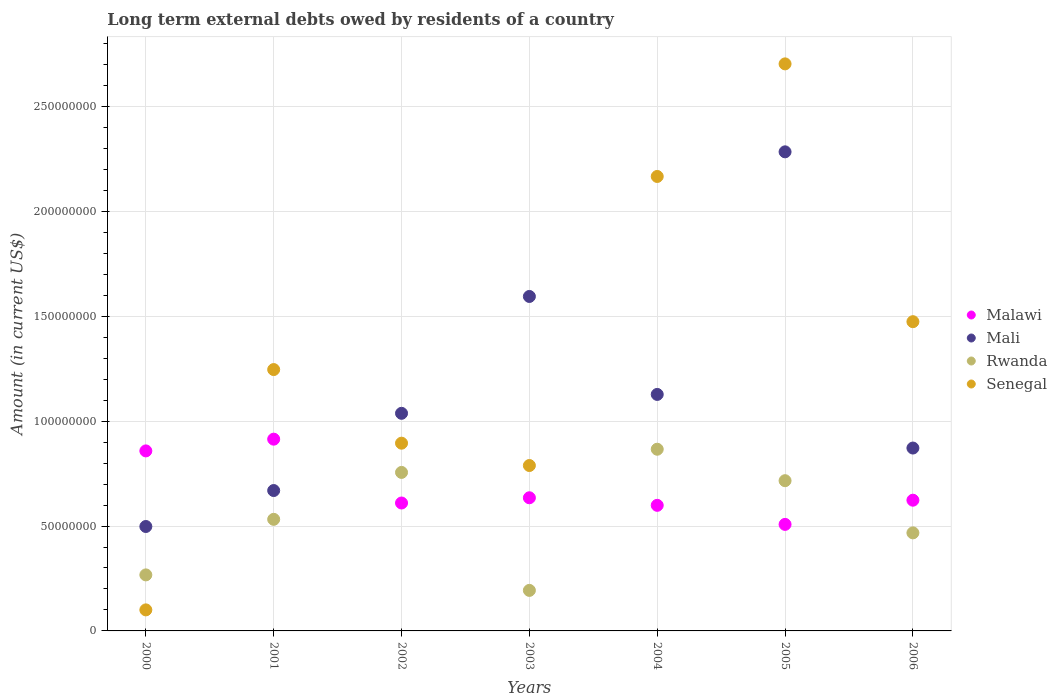How many different coloured dotlines are there?
Provide a short and direct response. 4. Is the number of dotlines equal to the number of legend labels?
Your answer should be very brief. Yes. What is the amount of long-term external debts owed by residents in Senegal in 2004?
Offer a very short reply. 2.17e+08. Across all years, what is the maximum amount of long-term external debts owed by residents in Malawi?
Offer a terse response. 9.14e+07. Across all years, what is the minimum amount of long-term external debts owed by residents in Rwanda?
Your response must be concise. 1.93e+07. In which year was the amount of long-term external debts owed by residents in Malawi maximum?
Offer a very short reply. 2001. In which year was the amount of long-term external debts owed by residents in Senegal minimum?
Offer a terse response. 2000. What is the total amount of long-term external debts owed by residents in Senegal in the graph?
Your response must be concise. 9.37e+08. What is the difference between the amount of long-term external debts owed by residents in Senegal in 2000 and that in 2004?
Provide a short and direct response. -2.07e+08. What is the difference between the amount of long-term external debts owed by residents in Rwanda in 2003 and the amount of long-term external debts owed by residents in Senegal in 2005?
Make the answer very short. -2.51e+08. What is the average amount of long-term external debts owed by residents in Senegal per year?
Your answer should be compact. 1.34e+08. In the year 2001, what is the difference between the amount of long-term external debts owed by residents in Mali and amount of long-term external debts owed by residents in Rwanda?
Ensure brevity in your answer.  1.37e+07. In how many years, is the amount of long-term external debts owed by residents in Senegal greater than 260000000 US$?
Provide a short and direct response. 1. What is the ratio of the amount of long-term external debts owed by residents in Senegal in 2000 to that in 2002?
Offer a very short reply. 0.11. Is the amount of long-term external debts owed by residents in Mali in 2000 less than that in 2001?
Offer a very short reply. Yes. Is the difference between the amount of long-term external debts owed by residents in Mali in 2002 and 2003 greater than the difference between the amount of long-term external debts owed by residents in Rwanda in 2002 and 2003?
Provide a short and direct response. No. What is the difference between the highest and the second highest amount of long-term external debts owed by residents in Senegal?
Your answer should be compact. 5.37e+07. What is the difference between the highest and the lowest amount of long-term external debts owed by residents in Senegal?
Provide a succinct answer. 2.60e+08. Is it the case that in every year, the sum of the amount of long-term external debts owed by residents in Senegal and amount of long-term external debts owed by residents in Mali  is greater than the sum of amount of long-term external debts owed by residents in Rwanda and amount of long-term external debts owed by residents in Malawi?
Make the answer very short. No. Is it the case that in every year, the sum of the amount of long-term external debts owed by residents in Malawi and amount of long-term external debts owed by residents in Mali  is greater than the amount of long-term external debts owed by residents in Rwanda?
Ensure brevity in your answer.  Yes. Does the amount of long-term external debts owed by residents in Malawi monotonically increase over the years?
Make the answer very short. No. Is the amount of long-term external debts owed by residents in Senegal strictly greater than the amount of long-term external debts owed by residents in Mali over the years?
Offer a very short reply. No. How many dotlines are there?
Provide a succinct answer. 4. How many years are there in the graph?
Your answer should be compact. 7. What is the difference between two consecutive major ticks on the Y-axis?
Give a very brief answer. 5.00e+07. Does the graph contain any zero values?
Your response must be concise. No. Where does the legend appear in the graph?
Provide a short and direct response. Center right. How many legend labels are there?
Give a very brief answer. 4. How are the legend labels stacked?
Provide a short and direct response. Vertical. What is the title of the graph?
Make the answer very short. Long term external debts owed by residents of a country. Does "Oman" appear as one of the legend labels in the graph?
Offer a very short reply. No. What is the label or title of the Y-axis?
Make the answer very short. Amount (in current US$). What is the Amount (in current US$) in Malawi in 2000?
Offer a very short reply. 8.58e+07. What is the Amount (in current US$) in Mali in 2000?
Your answer should be very brief. 4.98e+07. What is the Amount (in current US$) in Rwanda in 2000?
Offer a terse response. 2.67e+07. What is the Amount (in current US$) in Senegal in 2000?
Ensure brevity in your answer.  1.00e+07. What is the Amount (in current US$) in Malawi in 2001?
Provide a succinct answer. 9.14e+07. What is the Amount (in current US$) of Mali in 2001?
Give a very brief answer. 6.69e+07. What is the Amount (in current US$) in Rwanda in 2001?
Offer a very short reply. 5.32e+07. What is the Amount (in current US$) of Senegal in 2001?
Keep it short and to the point. 1.25e+08. What is the Amount (in current US$) in Malawi in 2002?
Give a very brief answer. 6.10e+07. What is the Amount (in current US$) of Mali in 2002?
Ensure brevity in your answer.  1.04e+08. What is the Amount (in current US$) of Rwanda in 2002?
Your answer should be compact. 7.56e+07. What is the Amount (in current US$) of Senegal in 2002?
Offer a terse response. 8.95e+07. What is the Amount (in current US$) in Malawi in 2003?
Your answer should be compact. 6.35e+07. What is the Amount (in current US$) of Mali in 2003?
Your answer should be compact. 1.59e+08. What is the Amount (in current US$) in Rwanda in 2003?
Ensure brevity in your answer.  1.93e+07. What is the Amount (in current US$) in Senegal in 2003?
Ensure brevity in your answer.  7.88e+07. What is the Amount (in current US$) of Malawi in 2004?
Provide a succinct answer. 5.99e+07. What is the Amount (in current US$) of Mali in 2004?
Your answer should be very brief. 1.13e+08. What is the Amount (in current US$) of Rwanda in 2004?
Your answer should be very brief. 8.66e+07. What is the Amount (in current US$) of Senegal in 2004?
Provide a succinct answer. 2.17e+08. What is the Amount (in current US$) in Malawi in 2005?
Your answer should be compact. 5.08e+07. What is the Amount (in current US$) in Mali in 2005?
Your answer should be very brief. 2.28e+08. What is the Amount (in current US$) of Rwanda in 2005?
Offer a terse response. 7.16e+07. What is the Amount (in current US$) in Senegal in 2005?
Keep it short and to the point. 2.70e+08. What is the Amount (in current US$) of Malawi in 2006?
Offer a very short reply. 6.23e+07. What is the Amount (in current US$) of Mali in 2006?
Your answer should be very brief. 8.72e+07. What is the Amount (in current US$) in Rwanda in 2006?
Your answer should be compact. 4.67e+07. What is the Amount (in current US$) in Senegal in 2006?
Make the answer very short. 1.47e+08. Across all years, what is the maximum Amount (in current US$) of Malawi?
Provide a short and direct response. 9.14e+07. Across all years, what is the maximum Amount (in current US$) of Mali?
Your answer should be very brief. 2.28e+08. Across all years, what is the maximum Amount (in current US$) in Rwanda?
Keep it short and to the point. 8.66e+07. Across all years, what is the maximum Amount (in current US$) of Senegal?
Give a very brief answer. 2.70e+08. Across all years, what is the minimum Amount (in current US$) in Malawi?
Make the answer very short. 5.08e+07. Across all years, what is the minimum Amount (in current US$) in Mali?
Give a very brief answer. 4.98e+07. Across all years, what is the minimum Amount (in current US$) of Rwanda?
Give a very brief answer. 1.93e+07. Across all years, what is the minimum Amount (in current US$) of Senegal?
Your response must be concise. 1.00e+07. What is the total Amount (in current US$) in Malawi in the graph?
Give a very brief answer. 4.75e+08. What is the total Amount (in current US$) of Mali in the graph?
Your response must be concise. 8.08e+08. What is the total Amount (in current US$) in Rwanda in the graph?
Provide a succinct answer. 3.80e+08. What is the total Amount (in current US$) in Senegal in the graph?
Ensure brevity in your answer.  9.37e+08. What is the difference between the Amount (in current US$) of Malawi in 2000 and that in 2001?
Offer a terse response. -5.60e+06. What is the difference between the Amount (in current US$) of Mali in 2000 and that in 2001?
Give a very brief answer. -1.71e+07. What is the difference between the Amount (in current US$) of Rwanda in 2000 and that in 2001?
Provide a short and direct response. -2.65e+07. What is the difference between the Amount (in current US$) of Senegal in 2000 and that in 2001?
Your response must be concise. -1.15e+08. What is the difference between the Amount (in current US$) of Malawi in 2000 and that in 2002?
Offer a terse response. 2.48e+07. What is the difference between the Amount (in current US$) of Mali in 2000 and that in 2002?
Provide a succinct answer. -5.40e+07. What is the difference between the Amount (in current US$) in Rwanda in 2000 and that in 2002?
Provide a succinct answer. -4.89e+07. What is the difference between the Amount (in current US$) in Senegal in 2000 and that in 2002?
Provide a succinct answer. -7.95e+07. What is the difference between the Amount (in current US$) in Malawi in 2000 and that in 2003?
Provide a short and direct response. 2.23e+07. What is the difference between the Amount (in current US$) of Mali in 2000 and that in 2003?
Provide a short and direct response. -1.10e+08. What is the difference between the Amount (in current US$) in Rwanda in 2000 and that in 2003?
Your response must be concise. 7.39e+06. What is the difference between the Amount (in current US$) of Senegal in 2000 and that in 2003?
Ensure brevity in your answer.  -6.88e+07. What is the difference between the Amount (in current US$) in Malawi in 2000 and that in 2004?
Make the answer very short. 2.59e+07. What is the difference between the Amount (in current US$) of Mali in 2000 and that in 2004?
Your response must be concise. -6.30e+07. What is the difference between the Amount (in current US$) of Rwanda in 2000 and that in 2004?
Give a very brief answer. -5.99e+07. What is the difference between the Amount (in current US$) of Senegal in 2000 and that in 2004?
Your answer should be very brief. -2.07e+08. What is the difference between the Amount (in current US$) of Malawi in 2000 and that in 2005?
Provide a succinct answer. 3.50e+07. What is the difference between the Amount (in current US$) of Mali in 2000 and that in 2005?
Provide a short and direct response. -1.79e+08. What is the difference between the Amount (in current US$) of Rwanda in 2000 and that in 2005?
Your answer should be very brief. -4.49e+07. What is the difference between the Amount (in current US$) of Senegal in 2000 and that in 2005?
Provide a succinct answer. -2.60e+08. What is the difference between the Amount (in current US$) in Malawi in 2000 and that in 2006?
Provide a succinct answer. 2.35e+07. What is the difference between the Amount (in current US$) in Mali in 2000 and that in 2006?
Your answer should be compact. -3.74e+07. What is the difference between the Amount (in current US$) of Rwanda in 2000 and that in 2006?
Your answer should be compact. -2.00e+07. What is the difference between the Amount (in current US$) in Senegal in 2000 and that in 2006?
Give a very brief answer. -1.37e+08. What is the difference between the Amount (in current US$) of Malawi in 2001 and that in 2002?
Your answer should be very brief. 3.04e+07. What is the difference between the Amount (in current US$) in Mali in 2001 and that in 2002?
Ensure brevity in your answer.  -3.68e+07. What is the difference between the Amount (in current US$) in Rwanda in 2001 and that in 2002?
Make the answer very short. -2.24e+07. What is the difference between the Amount (in current US$) of Senegal in 2001 and that in 2002?
Your answer should be compact. 3.51e+07. What is the difference between the Amount (in current US$) of Malawi in 2001 and that in 2003?
Keep it short and to the point. 2.79e+07. What is the difference between the Amount (in current US$) of Mali in 2001 and that in 2003?
Provide a short and direct response. -9.25e+07. What is the difference between the Amount (in current US$) in Rwanda in 2001 and that in 2003?
Your answer should be very brief. 3.39e+07. What is the difference between the Amount (in current US$) of Senegal in 2001 and that in 2003?
Your response must be concise. 4.57e+07. What is the difference between the Amount (in current US$) of Malawi in 2001 and that in 2004?
Provide a succinct answer. 3.15e+07. What is the difference between the Amount (in current US$) of Mali in 2001 and that in 2004?
Offer a very short reply. -4.58e+07. What is the difference between the Amount (in current US$) of Rwanda in 2001 and that in 2004?
Keep it short and to the point. -3.34e+07. What is the difference between the Amount (in current US$) of Senegal in 2001 and that in 2004?
Offer a terse response. -9.21e+07. What is the difference between the Amount (in current US$) of Malawi in 2001 and that in 2005?
Your response must be concise. 4.06e+07. What is the difference between the Amount (in current US$) of Mali in 2001 and that in 2005?
Provide a short and direct response. -1.61e+08. What is the difference between the Amount (in current US$) of Rwanda in 2001 and that in 2005?
Your answer should be compact. -1.84e+07. What is the difference between the Amount (in current US$) of Senegal in 2001 and that in 2005?
Offer a terse response. -1.46e+08. What is the difference between the Amount (in current US$) of Malawi in 2001 and that in 2006?
Your answer should be very brief. 2.91e+07. What is the difference between the Amount (in current US$) of Mali in 2001 and that in 2006?
Your response must be concise. -2.03e+07. What is the difference between the Amount (in current US$) in Rwanda in 2001 and that in 2006?
Your response must be concise. 6.45e+06. What is the difference between the Amount (in current US$) in Senegal in 2001 and that in 2006?
Offer a very short reply. -2.28e+07. What is the difference between the Amount (in current US$) in Malawi in 2002 and that in 2003?
Your response must be concise. -2.49e+06. What is the difference between the Amount (in current US$) of Mali in 2002 and that in 2003?
Make the answer very short. -5.57e+07. What is the difference between the Amount (in current US$) of Rwanda in 2002 and that in 2003?
Offer a very short reply. 5.62e+07. What is the difference between the Amount (in current US$) of Senegal in 2002 and that in 2003?
Provide a short and direct response. 1.07e+07. What is the difference between the Amount (in current US$) of Malawi in 2002 and that in 2004?
Offer a terse response. 1.11e+06. What is the difference between the Amount (in current US$) in Mali in 2002 and that in 2004?
Make the answer very short. -9.00e+06. What is the difference between the Amount (in current US$) in Rwanda in 2002 and that in 2004?
Your answer should be very brief. -1.11e+07. What is the difference between the Amount (in current US$) of Senegal in 2002 and that in 2004?
Ensure brevity in your answer.  -1.27e+08. What is the difference between the Amount (in current US$) of Malawi in 2002 and that in 2005?
Provide a short and direct response. 1.02e+07. What is the difference between the Amount (in current US$) of Mali in 2002 and that in 2005?
Provide a succinct answer. -1.25e+08. What is the difference between the Amount (in current US$) of Rwanda in 2002 and that in 2005?
Provide a succinct answer. 3.94e+06. What is the difference between the Amount (in current US$) in Senegal in 2002 and that in 2005?
Your answer should be compact. -1.81e+08. What is the difference between the Amount (in current US$) of Malawi in 2002 and that in 2006?
Ensure brevity in your answer.  -1.34e+06. What is the difference between the Amount (in current US$) of Mali in 2002 and that in 2006?
Your answer should be very brief. 1.66e+07. What is the difference between the Amount (in current US$) of Rwanda in 2002 and that in 2006?
Your response must be concise. 2.88e+07. What is the difference between the Amount (in current US$) of Senegal in 2002 and that in 2006?
Offer a very short reply. -5.79e+07. What is the difference between the Amount (in current US$) in Malawi in 2003 and that in 2004?
Offer a very short reply. 3.60e+06. What is the difference between the Amount (in current US$) in Mali in 2003 and that in 2004?
Provide a succinct answer. 4.67e+07. What is the difference between the Amount (in current US$) of Rwanda in 2003 and that in 2004?
Your response must be concise. -6.73e+07. What is the difference between the Amount (in current US$) in Senegal in 2003 and that in 2004?
Your answer should be compact. -1.38e+08. What is the difference between the Amount (in current US$) of Malawi in 2003 and that in 2005?
Offer a very short reply. 1.27e+07. What is the difference between the Amount (in current US$) in Mali in 2003 and that in 2005?
Provide a short and direct response. -6.89e+07. What is the difference between the Amount (in current US$) in Rwanda in 2003 and that in 2005?
Give a very brief answer. -5.23e+07. What is the difference between the Amount (in current US$) in Senegal in 2003 and that in 2005?
Provide a succinct answer. -1.91e+08. What is the difference between the Amount (in current US$) in Malawi in 2003 and that in 2006?
Provide a succinct answer. 1.15e+06. What is the difference between the Amount (in current US$) of Mali in 2003 and that in 2006?
Offer a very short reply. 7.23e+07. What is the difference between the Amount (in current US$) of Rwanda in 2003 and that in 2006?
Your answer should be very brief. -2.74e+07. What is the difference between the Amount (in current US$) of Senegal in 2003 and that in 2006?
Keep it short and to the point. -6.86e+07. What is the difference between the Amount (in current US$) in Malawi in 2004 and that in 2005?
Offer a terse response. 9.09e+06. What is the difference between the Amount (in current US$) in Mali in 2004 and that in 2005?
Provide a short and direct response. -1.16e+08. What is the difference between the Amount (in current US$) in Rwanda in 2004 and that in 2005?
Provide a succinct answer. 1.50e+07. What is the difference between the Amount (in current US$) in Senegal in 2004 and that in 2005?
Make the answer very short. -5.37e+07. What is the difference between the Amount (in current US$) in Malawi in 2004 and that in 2006?
Give a very brief answer. -2.45e+06. What is the difference between the Amount (in current US$) in Mali in 2004 and that in 2006?
Provide a succinct answer. 2.56e+07. What is the difference between the Amount (in current US$) in Rwanda in 2004 and that in 2006?
Ensure brevity in your answer.  3.99e+07. What is the difference between the Amount (in current US$) of Senegal in 2004 and that in 2006?
Give a very brief answer. 6.92e+07. What is the difference between the Amount (in current US$) of Malawi in 2005 and that in 2006?
Offer a very short reply. -1.15e+07. What is the difference between the Amount (in current US$) in Mali in 2005 and that in 2006?
Your response must be concise. 1.41e+08. What is the difference between the Amount (in current US$) in Rwanda in 2005 and that in 2006?
Make the answer very short. 2.49e+07. What is the difference between the Amount (in current US$) in Senegal in 2005 and that in 2006?
Offer a terse response. 1.23e+08. What is the difference between the Amount (in current US$) in Malawi in 2000 and the Amount (in current US$) in Mali in 2001?
Give a very brief answer. 1.89e+07. What is the difference between the Amount (in current US$) in Malawi in 2000 and the Amount (in current US$) in Rwanda in 2001?
Your answer should be compact. 3.26e+07. What is the difference between the Amount (in current US$) of Malawi in 2000 and the Amount (in current US$) of Senegal in 2001?
Make the answer very short. -3.88e+07. What is the difference between the Amount (in current US$) in Mali in 2000 and the Amount (in current US$) in Rwanda in 2001?
Keep it short and to the point. -3.42e+06. What is the difference between the Amount (in current US$) in Mali in 2000 and the Amount (in current US$) in Senegal in 2001?
Provide a succinct answer. -7.48e+07. What is the difference between the Amount (in current US$) in Rwanda in 2000 and the Amount (in current US$) in Senegal in 2001?
Your response must be concise. -9.79e+07. What is the difference between the Amount (in current US$) of Malawi in 2000 and the Amount (in current US$) of Mali in 2002?
Offer a terse response. -1.79e+07. What is the difference between the Amount (in current US$) in Malawi in 2000 and the Amount (in current US$) in Rwanda in 2002?
Your answer should be compact. 1.03e+07. What is the difference between the Amount (in current US$) of Malawi in 2000 and the Amount (in current US$) of Senegal in 2002?
Make the answer very short. -3.68e+06. What is the difference between the Amount (in current US$) in Mali in 2000 and the Amount (in current US$) in Rwanda in 2002?
Give a very brief answer. -2.58e+07. What is the difference between the Amount (in current US$) in Mali in 2000 and the Amount (in current US$) in Senegal in 2002?
Offer a very short reply. -3.97e+07. What is the difference between the Amount (in current US$) in Rwanda in 2000 and the Amount (in current US$) in Senegal in 2002?
Provide a short and direct response. -6.28e+07. What is the difference between the Amount (in current US$) in Malawi in 2000 and the Amount (in current US$) in Mali in 2003?
Your response must be concise. -7.36e+07. What is the difference between the Amount (in current US$) in Malawi in 2000 and the Amount (in current US$) in Rwanda in 2003?
Your answer should be very brief. 6.65e+07. What is the difference between the Amount (in current US$) in Malawi in 2000 and the Amount (in current US$) in Senegal in 2003?
Keep it short and to the point. 6.97e+06. What is the difference between the Amount (in current US$) in Mali in 2000 and the Amount (in current US$) in Rwanda in 2003?
Offer a terse response. 3.05e+07. What is the difference between the Amount (in current US$) in Mali in 2000 and the Amount (in current US$) in Senegal in 2003?
Give a very brief answer. -2.91e+07. What is the difference between the Amount (in current US$) of Rwanda in 2000 and the Amount (in current US$) of Senegal in 2003?
Your answer should be compact. -5.21e+07. What is the difference between the Amount (in current US$) of Malawi in 2000 and the Amount (in current US$) of Mali in 2004?
Give a very brief answer. -2.69e+07. What is the difference between the Amount (in current US$) in Malawi in 2000 and the Amount (in current US$) in Rwanda in 2004?
Give a very brief answer. -7.97e+05. What is the difference between the Amount (in current US$) of Malawi in 2000 and the Amount (in current US$) of Senegal in 2004?
Give a very brief answer. -1.31e+08. What is the difference between the Amount (in current US$) of Mali in 2000 and the Amount (in current US$) of Rwanda in 2004?
Offer a terse response. -3.68e+07. What is the difference between the Amount (in current US$) in Mali in 2000 and the Amount (in current US$) in Senegal in 2004?
Provide a succinct answer. -1.67e+08. What is the difference between the Amount (in current US$) of Rwanda in 2000 and the Amount (in current US$) of Senegal in 2004?
Your answer should be very brief. -1.90e+08. What is the difference between the Amount (in current US$) of Malawi in 2000 and the Amount (in current US$) of Mali in 2005?
Offer a very short reply. -1.43e+08. What is the difference between the Amount (in current US$) of Malawi in 2000 and the Amount (in current US$) of Rwanda in 2005?
Provide a short and direct response. 1.42e+07. What is the difference between the Amount (in current US$) in Malawi in 2000 and the Amount (in current US$) in Senegal in 2005?
Your answer should be very brief. -1.84e+08. What is the difference between the Amount (in current US$) of Mali in 2000 and the Amount (in current US$) of Rwanda in 2005?
Your answer should be compact. -2.18e+07. What is the difference between the Amount (in current US$) in Mali in 2000 and the Amount (in current US$) in Senegal in 2005?
Your response must be concise. -2.21e+08. What is the difference between the Amount (in current US$) in Rwanda in 2000 and the Amount (in current US$) in Senegal in 2005?
Ensure brevity in your answer.  -2.44e+08. What is the difference between the Amount (in current US$) of Malawi in 2000 and the Amount (in current US$) of Mali in 2006?
Your response must be concise. -1.36e+06. What is the difference between the Amount (in current US$) of Malawi in 2000 and the Amount (in current US$) of Rwanda in 2006?
Ensure brevity in your answer.  3.91e+07. What is the difference between the Amount (in current US$) of Malawi in 2000 and the Amount (in current US$) of Senegal in 2006?
Offer a terse response. -6.16e+07. What is the difference between the Amount (in current US$) of Mali in 2000 and the Amount (in current US$) of Rwanda in 2006?
Ensure brevity in your answer.  3.04e+06. What is the difference between the Amount (in current US$) in Mali in 2000 and the Amount (in current US$) in Senegal in 2006?
Keep it short and to the point. -9.76e+07. What is the difference between the Amount (in current US$) of Rwanda in 2000 and the Amount (in current US$) of Senegal in 2006?
Your response must be concise. -1.21e+08. What is the difference between the Amount (in current US$) of Malawi in 2001 and the Amount (in current US$) of Mali in 2002?
Your answer should be compact. -1.23e+07. What is the difference between the Amount (in current US$) of Malawi in 2001 and the Amount (in current US$) of Rwanda in 2002?
Ensure brevity in your answer.  1.59e+07. What is the difference between the Amount (in current US$) of Malawi in 2001 and the Amount (in current US$) of Senegal in 2002?
Your answer should be compact. 1.91e+06. What is the difference between the Amount (in current US$) of Mali in 2001 and the Amount (in current US$) of Rwanda in 2002?
Your answer should be compact. -8.64e+06. What is the difference between the Amount (in current US$) in Mali in 2001 and the Amount (in current US$) in Senegal in 2002?
Provide a succinct answer. -2.26e+07. What is the difference between the Amount (in current US$) in Rwanda in 2001 and the Amount (in current US$) in Senegal in 2002?
Your answer should be compact. -3.63e+07. What is the difference between the Amount (in current US$) of Malawi in 2001 and the Amount (in current US$) of Mali in 2003?
Offer a terse response. -6.80e+07. What is the difference between the Amount (in current US$) in Malawi in 2001 and the Amount (in current US$) in Rwanda in 2003?
Keep it short and to the point. 7.21e+07. What is the difference between the Amount (in current US$) in Malawi in 2001 and the Amount (in current US$) in Senegal in 2003?
Ensure brevity in your answer.  1.26e+07. What is the difference between the Amount (in current US$) of Mali in 2001 and the Amount (in current US$) of Rwanda in 2003?
Keep it short and to the point. 4.76e+07. What is the difference between the Amount (in current US$) of Mali in 2001 and the Amount (in current US$) of Senegal in 2003?
Your answer should be compact. -1.19e+07. What is the difference between the Amount (in current US$) in Rwanda in 2001 and the Amount (in current US$) in Senegal in 2003?
Your answer should be very brief. -2.57e+07. What is the difference between the Amount (in current US$) of Malawi in 2001 and the Amount (in current US$) of Mali in 2004?
Offer a very short reply. -2.13e+07. What is the difference between the Amount (in current US$) of Malawi in 2001 and the Amount (in current US$) of Rwanda in 2004?
Offer a very short reply. 4.80e+06. What is the difference between the Amount (in current US$) of Malawi in 2001 and the Amount (in current US$) of Senegal in 2004?
Offer a very short reply. -1.25e+08. What is the difference between the Amount (in current US$) in Mali in 2001 and the Amount (in current US$) in Rwanda in 2004?
Make the answer very short. -1.97e+07. What is the difference between the Amount (in current US$) in Mali in 2001 and the Amount (in current US$) in Senegal in 2004?
Offer a very short reply. -1.50e+08. What is the difference between the Amount (in current US$) of Rwanda in 2001 and the Amount (in current US$) of Senegal in 2004?
Offer a terse response. -1.63e+08. What is the difference between the Amount (in current US$) of Malawi in 2001 and the Amount (in current US$) of Mali in 2005?
Your response must be concise. -1.37e+08. What is the difference between the Amount (in current US$) of Malawi in 2001 and the Amount (in current US$) of Rwanda in 2005?
Give a very brief answer. 1.98e+07. What is the difference between the Amount (in current US$) in Malawi in 2001 and the Amount (in current US$) in Senegal in 2005?
Offer a terse response. -1.79e+08. What is the difference between the Amount (in current US$) in Mali in 2001 and the Amount (in current US$) in Rwanda in 2005?
Provide a short and direct response. -4.70e+06. What is the difference between the Amount (in current US$) of Mali in 2001 and the Amount (in current US$) of Senegal in 2005?
Keep it short and to the point. -2.03e+08. What is the difference between the Amount (in current US$) in Rwanda in 2001 and the Amount (in current US$) in Senegal in 2005?
Offer a very short reply. -2.17e+08. What is the difference between the Amount (in current US$) in Malawi in 2001 and the Amount (in current US$) in Mali in 2006?
Your answer should be compact. 4.23e+06. What is the difference between the Amount (in current US$) in Malawi in 2001 and the Amount (in current US$) in Rwanda in 2006?
Your answer should be compact. 4.47e+07. What is the difference between the Amount (in current US$) in Malawi in 2001 and the Amount (in current US$) in Senegal in 2006?
Provide a short and direct response. -5.60e+07. What is the difference between the Amount (in current US$) of Mali in 2001 and the Amount (in current US$) of Rwanda in 2006?
Make the answer very short. 2.02e+07. What is the difference between the Amount (in current US$) in Mali in 2001 and the Amount (in current US$) in Senegal in 2006?
Provide a short and direct response. -8.05e+07. What is the difference between the Amount (in current US$) of Rwanda in 2001 and the Amount (in current US$) of Senegal in 2006?
Give a very brief answer. -9.42e+07. What is the difference between the Amount (in current US$) in Malawi in 2002 and the Amount (in current US$) in Mali in 2003?
Your answer should be very brief. -9.85e+07. What is the difference between the Amount (in current US$) of Malawi in 2002 and the Amount (in current US$) of Rwanda in 2003?
Your answer should be very brief. 4.17e+07. What is the difference between the Amount (in current US$) of Malawi in 2002 and the Amount (in current US$) of Senegal in 2003?
Your answer should be very brief. -1.79e+07. What is the difference between the Amount (in current US$) in Mali in 2002 and the Amount (in current US$) in Rwanda in 2003?
Provide a succinct answer. 8.44e+07. What is the difference between the Amount (in current US$) in Mali in 2002 and the Amount (in current US$) in Senegal in 2003?
Keep it short and to the point. 2.49e+07. What is the difference between the Amount (in current US$) in Rwanda in 2002 and the Amount (in current US$) in Senegal in 2003?
Offer a terse response. -3.28e+06. What is the difference between the Amount (in current US$) of Malawi in 2002 and the Amount (in current US$) of Mali in 2004?
Give a very brief answer. -5.18e+07. What is the difference between the Amount (in current US$) in Malawi in 2002 and the Amount (in current US$) in Rwanda in 2004?
Provide a short and direct response. -2.56e+07. What is the difference between the Amount (in current US$) in Malawi in 2002 and the Amount (in current US$) in Senegal in 2004?
Ensure brevity in your answer.  -1.56e+08. What is the difference between the Amount (in current US$) of Mali in 2002 and the Amount (in current US$) of Rwanda in 2004?
Your answer should be very brief. 1.71e+07. What is the difference between the Amount (in current US$) of Mali in 2002 and the Amount (in current US$) of Senegal in 2004?
Your response must be concise. -1.13e+08. What is the difference between the Amount (in current US$) of Rwanda in 2002 and the Amount (in current US$) of Senegal in 2004?
Give a very brief answer. -1.41e+08. What is the difference between the Amount (in current US$) of Malawi in 2002 and the Amount (in current US$) of Mali in 2005?
Offer a terse response. -1.67e+08. What is the difference between the Amount (in current US$) of Malawi in 2002 and the Amount (in current US$) of Rwanda in 2005?
Offer a terse response. -1.06e+07. What is the difference between the Amount (in current US$) of Malawi in 2002 and the Amount (in current US$) of Senegal in 2005?
Give a very brief answer. -2.09e+08. What is the difference between the Amount (in current US$) in Mali in 2002 and the Amount (in current US$) in Rwanda in 2005?
Provide a short and direct response. 3.21e+07. What is the difference between the Amount (in current US$) in Mali in 2002 and the Amount (in current US$) in Senegal in 2005?
Give a very brief answer. -1.67e+08. What is the difference between the Amount (in current US$) in Rwanda in 2002 and the Amount (in current US$) in Senegal in 2005?
Offer a very short reply. -1.95e+08. What is the difference between the Amount (in current US$) of Malawi in 2002 and the Amount (in current US$) of Mali in 2006?
Provide a succinct answer. -2.62e+07. What is the difference between the Amount (in current US$) in Malawi in 2002 and the Amount (in current US$) in Rwanda in 2006?
Offer a very short reply. 1.42e+07. What is the difference between the Amount (in current US$) of Malawi in 2002 and the Amount (in current US$) of Senegal in 2006?
Offer a terse response. -8.64e+07. What is the difference between the Amount (in current US$) of Mali in 2002 and the Amount (in current US$) of Rwanda in 2006?
Offer a terse response. 5.70e+07. What is the difference between the Amount (in current US$) in Mali in 2002 and the Amount (in current US$) in Senegal in 2006?
Your answer should be compact. -4.37e+07. What is the difference between the Amount (in current US$) in Rwanda in 2002 and the Amount (in current US$) in Senegal in 2006?
Your answer should be compact. -7.19e+07. What is the difference between the Amount (in current US$) in Malawi in 2003 and the Amount (in current US$) in Mali in 2004?
Keep it short and to the point. -4.93e+07. What is the difference between the Amount (in current US$) of Malawi in 2003 and the Amount (in current US$) of Rwanda in 2004?
Ensure brevity in your answer.  -2.31e+07. What is the difference between the Amount (in current US$) in Malawi in 2003 and the Amount (in current US$) in Senegal in 2004?
Provide a short and direct response. -1.53e+08. What is the difference between the Amount (in current US$) of Mali in 2003 and the Amount (in current US$) of Rwanda in 2004?
Your response must be concise. 7.28e+07. What is the difference between the Amount (in current US$) in Mali in 2003 and the Amount (in current US$) in Senegal in 2004?
Your answer should be very brief. -5.72e+07. What is the difference between the Amount (in current US$) in Rwanda in 2003 and the Amount (in current US$) in Senegal in 2004?
Give a very brief answer. -1.97e+08. What is the difference between the Amount (in current US$) in Malawi in 2003 and the Amount (in current US$) in Mali in 2005?
Your answer should be compact. -1.65e+08. What is the difference between the Amount (in current US$) in Malawi in 2003 and the Amount (in current US$) in Rwanda in 2005?
Keep it short and to the point. -8.14e+06. What is the difference between the Amount (in current US$) in Malawi in 2003 and the Amount (in current US$) in Senegal in 2005?
Offer a very short reply. -2.07e+08. What is the difference between the Amount (in current US$) in Mali in 2003 and the Amount (in current US$) in Rwanda in 2005?
Offer a terse response. 8.78e+07. What is the difference between the Amount (in current US$) of Mali in 2003 and the Amount (in current US$) of Senegal in 2005?
Offer a terse response. -1.11e+08. What is the difference between the Amount (in current US$) of Rwanda in 2003 and the Amount (in current US$) of Senegal in 2005?
Keep it short and to the point. -2.51e+08. What is the difference between the Amount (in current US$) of Malawi in 2003 and the Amount (in current US$) of Mali in 2006?
Give a very brief answer. -2.37e+07. What is the difference between the Amount (in current US$) in Malawi in 2003 and the Amount (in current US$) in Rwanda in 2006?
Give a very brief answer. 1.67e+07. What is the difference between the Amount (in current US$) in Malawi in 2003 and the Amount (in current US$) in Senegal in 2006?
Provide a short and direct response. -8.39e+07. What is the difference between the Amount (in current US$) in Mali in 2003 and the Amount (in current US$) in Rwanda in 2006?
Make the answer very short. 1.13e+08. What is the difference between the Amount (in current US$) of Mali in 2003 and the Amount (in current US$) of Senegal in 2006?
Provide a succinct answer. 1.20e+07. What is the difference between the Amount (in current US$) in Rwanda in 2003 and the Amount (in current US$) in Senegal in 2006?
Ensure brevity in your answer.  -1.28e+08. What is the difference between the Amount (in current US$) in Malawi in 2004 and the Amount (in current US$) in Mali in 2005?
Ensure brevity in your answer.  -1.69e+08. What is the difference between the Amount (in current US$) in Malawi in 2004 and the Amount (in current US$) in Rwanda in 2005?
Offer a terse response. -1.17e+07. What is the difference between the Amount (in current US$) in Malawi in 2004 and the Amount (in current US$) in Senegal in 2005?
Your answer should be very brief. -2.10e+08. What is the difference between the Amount (in current US$) of Mali in 2004 and the Amount (in current US$) of Rwanda in 2005?
Your answer should be compact. 4.11e+07. What is the difference between the Amount (in current US$) in Mali in 2004 and the Amount (in current US$) in Senegal in 2005?
Provide a short and direct response. -1.58e+08. What is the difference between the Amount (in current US$) in Rwanda in 2004 and the Amount (in current US$) in Senegal in 2005?
Keep it short and to the point. -1.84e+08. What is the difference between the Amount (in current US$) in Malawi in 2004 and the Amount (in current US$) in Mali in 2006?
Your answer should be compact. -2.73e+07. What is the difference between the Amount (in current US$) of Malawi in 2004 and the Amount (in current US$) of Rwanda in 2006?
Give a very brief answer. 1.31e+07. What is the difference between the Amount (in current US$) in Malawi in 2004 and the Amount (in current US$) in Senegal in 2006?
Provide a succinct answer. -8.75e+07. What is the difference between the Amount (in current US$) of Mali in 2004 and the Amount (in current US$) of Rwanda in 2006?
Provide a short and direct response. 6.60e+07. What is the difference between the Amount (in current US$) of Mali in 2004 and the Amount (in current US$) of Senegal in 2006?
Ensure brevity in your answer.  -3.47e+07. What is the difference between the Amount (in current US$) of Rwanda in 2004 and the Amount (in current US$) of Senegal in 2006?
Ensure brevity in your answer.  -6.08e+07. What is the difference between the Amount (in current US$) in Malawi in 2005 and the Amount (in current US$) in Mali in 2006?
Provide a short and direct response. -3.64e+07. What is the difference between the Amount (in current US$) of Malawi in 2005 and the Amount (in current US$) of Rwanda in 2006?
Provide a succinct answer. 4.04e+06. What is the difference between the Amount (in current US$) of Malawi in 2005 and the Amount (in current US$) of Senegal in 2006?
Give a very brief answer. -9.66e+07. What is the difference between the Amount (in current US$) of Mali in 2005 and the Amount (in current US$) of Rwanda in 2006?
Your response must be concise. 1.82e+08. What is the difference between the Amount (in current US$) of Mali in 2005 and the Amount (in current US$) of Senegal in 2006?
Ensure brevity in your answer.  8.10e+07. What is the difference between the Amount (in current US$) in Rwanda in 2005 and the Amount (in current US$) in Senegal in 2006?
Make the answer very short. -7.58e+07. What is the average Amount (in current US$) of Malawi per year?
Keep it short and to the point. 6.78e+07. What is the average Amount (in current US$) of Mali per year?
Ensure brevity in your answer.  1.15e+08. What is the average Amount (in current US$) of Rwanda per year?
Ensure brevity in your answer.  5.43e+07. What is the average Amount (in current US$) in Senegal per year?
Give a very brief answer. 1.34e+08. In the year 2000, what is the difference between the Amount (in current US$) of Malawi and Amount (in current US$) of Mali?
Ensure brevity in your answer.  3.60e+07. In the year 2000, what is the difference between the Amount (in current US$) in Malawi and Amount (in current US$) in Rwanda?
Provide a short and direct response. 5.91e+07. In the year 2000, what is the difference between the Amount (in current US$) in Malawi and Amount (in current US$) in Senegal?
Make the answer very short. 7.58e+07. In the year 2000, what is the difference between the Amount (in current US$) in Mali and Amount (in current US$) in Rwanda?
Your response must be concise. 2.31e+07. In the year 2000, what is the difference between the Amount (in current US$) of Mali and Amount (in current US$) of Senegal?
Offer a very short reply. 3.97e+07. In the year 2000, what is the difference between the Amount (in current US$) of Rwanda and Amount (in current US$) of Senegal?
Your response must be concise. 1.67e+07. In the year 2001, what is the difference between the Amount (in current US$) in Malawi and Amount (in current US$) in Mali?
Provide a short and direct response. 2.45e+07. In the year 2001, what is the difference between the Amount (in current US$) of Malawi and Amount (in current US$) of Rwanda?
Provide a short and direct response. 3.82e+07. In the year 2001, what is the difference between the Amount (in current US$) of Malawi and Amount (in current US$) of Senegal?
Offer a very short reply. -3.32e+07. In the year 2001, what is the difference between the Amount (in current US$) in Mali and Amount (in current US$) in Rwanda?
Ensure brevity in your answer.  1.37e+07. In the year 2001, what is the difference between the Amount (in current US$) of Mali and Amount (in current US$) of Senegal?
Make the answer very short. -5.77e+07. In the year 2001, what is the difference between the Amount (in current US$) in Rwanda and Amount (in current US$) in Senegal?
Your answer should be very brief. -7.14e+07. In the year 2002, what is the difference between the Amount (in current US$) in Malawi and Amount (in current US$) in Mali?
Your answer should be very brief. -4.28e+07. In the year 2002, what is the difference between the Amount (in current US$) in Malawi and Amount (in current US$) in Rwanda?
Provide a short and direct response. -1.46e+07. In the year 2002, what is the difference between the Amount (in current US$) in Malawi and Amount (in current US$) in Senegal?
Make the answer very short. -2.85e+07. In the year 2002, what is the difference between the Amount (in current US$) in Mali and Amount (in current US$) in Rwanda?
Give a very brief answer. 2.82e+07. In the year 2002, what is the difference between the Amount (in current US$) in Mali and Amount (in current US$) in Senegal?
Your response must be concise. 1.42e+07. In the year 2002, what is the difference between the Amount (in current US$) of Rwanda and Amount (in current US$) of Senegal?
Your response must be concise. -1.39e+07. In the year 2003, what is the difference between the Amount (in current US$) in Malawi and Amount (in current US$) in Mali?
Provide a succinct answer. -9.60e+07. In the year 2003, what is the difference between the Amount (in current US$) of Malawi and Amount (in current US$) of Rwanda?
Offer a very short reply. 4.42e+07. In the year 2003, what is the difference between the Amount (in current US$) of Malawi and Amount (in current US$) of Senegal?
Your response must be concise. -1.54e+07. In the year 2003, what is the difference between the Amount (in current US$) in Mali and Amount (in current US$) in Rwanda?
Provide a succinct answer. 1.40e+08. In the year 2003, what is the difference between the Amount (in current US$) in Mali and Amount (in current US$) in Senegal?
Ensure brevity in your answer.  8.06e+07. In the year 2003, what is the difference between the Amount (in current US$) in Rwanda and Amount (in current US$) in Senegal?
Offer a very short reply. -5.95e+07. In the year 2004, what is the difference between the Amount (in current US$) in Malawi and Amount (in current US$) in Mali?
Offer a very short reply. -5.29e+07. In the year 2004, what is the difference between the Amount (in current US$) of Malawi and Amount (in current US$) of Rwanda?
Your answer should be compact. -2.67e+07. In the year 2004, what is the difference between the Amount (in current US$) of Malawi and Amount (in current US$) of Senegal?
Offer a terse response. -1.57e+08. In the year 2004, what is the difference between the Amount (in current US$) of Mali and Amount (in current US$) of Rwanda?
Provide a short and direct response. 2.61e+07. In the year 2004, what is the difference between the Amount (in current US$) in Mali and Amount (in current US$) in Senegal?
Provide a succinct answer. -1.04e+08. In the year 2004, what is the difference between the Amount (in current US$) in Rwanda and Amount (in current US$) in Senegal?
Offer a very short reply. -1.30e+08. In the year 2005, what is the difference between the Amount (in current US$) of Malawi and Amount (in current US$) of Mali?
Offer a very short reply. -1.78e+08. In the year 2005, what is the difference between the Amount (in current US$) of Malawi and Amount (in current US$) of Rwanda?
Make the answer very short. -2.08e+07. In the year 2005, what is the difference between the Amount (in current US$) of Malawi and Amount (in current US$) of Senegal?
Your response must be concise. -2.20e+08. In the year 2005, what is the difference between the Amount (in current US$) of Mali and Amount (in current US$) of Rwanda?
Your answer should be compact. 1.57e+08. In the year 2005, what is the difference between the Amount (in current US$) of Mali and Amount (in current US$) of Senegal?
Give a very brief answer. -4.19e+07. In the year 2005, what is the difference between the Amount (in current US$) in Rwanda and Amount (in current US$) in Senegal?
Keep it short and to the point. -1.99e+08. In the year 2006, what is the difference between the Amount (in current US$) in Malawi and Amount (in current US$) in Mali?
Offer a very short reply. -2.49e+07. In the year 2006, what is the difference between the Amount (in current US$) in Malawi and Amount (in current US$) in Rwanda?
Provide a short and direct response. 1.56e+07. In the year 2006, what is the difference between the Amount (in current US$) of Malawi and Amount (in current US$) of Senegal?
Offer a terse response. -8.51e+07. In the year 2006, what is the difference between the Amount (in current US$) in Mali and Amount (in current US$) in Rwanda?
Provide a short and direct response. 4.04e+07. In the year 2006, what is the difference between the Amount (in current US$) of Mali and Amount (in current US$) of Senegal?
Make the answer very short. -6.02e+07. In the year 2006, what is the difference between the Amount (in current US$) in Rwanda and Amount (in current US$) in Senegal?
Provide a short and direct response. -1.01e+08. What is the ratio of the Amount (in current US$) in Malawi in 2000 to that in 2001?
Ensure brevity in your answer.  0.94. What is the ratio of the Amount (in current US$) in Mali in 2000 to that in 2001?
Keep it short and to the point. 0.74. What is the ratio of the Amount (in current US$) of Rwanda in 2000 to that in 2001?
Provide a succinct answer. 0.5. What is the ratio of the Amount (in current US$) in Senegal in 2000 to that in 2001?
Ensure brevity in your answer.  0.08. What is the ratio of the Amount (in current US$) in Malawi in 2000 to that in 2002?
Keep it short and to the point. 1.41. What is the ratio of the Amount (in current US$) in Mali in 2000 to that in 2002?
Ensure brevity in your answer.  0.48. What is the ratio of the Amount (in current US$) of Rwanda in 2000 to that in 2002?
Offer a terse response. 0.35. What is the ratio of the Amount (in current US$) of Senegal in 2000 to that in 2002?
Your response must be concise. 0.11. What is the ratio of the Amount (in current US$) of Malawi in 2000 to that in 2003?
Your response must be concise. 1.35. What is the ratio of the Amount (in current US$) of Mali in 2000 to that in 2003?
Offer a very short reply. 0.31. What is the ratio of the Amount (in current US$) of Rwanda in 2000 to that in 2003?
Your answer should be compact. 1.38. What is the ratio of the Amount (in current US$) of Senegal in 2000 to that in 2003?
Keep it short and to the point. 0.13. What is the ratio of the Amount (in current US$) of Malawi in 2000 to that in 2004?
Provide a succinct answer. 1.43. What is the ratio of the Amount (in current US$) of Mali in 2000 to that in 2004?
Your answer should be compact. 0.44. What is the ratio of the Amount (in current US$) of Rwanda in 2000 to that in 2004?
Ensure brevity in your answer.  0.31. What is the ratio of the Amount (in current US$) in Senegal in 2000 to that in 2004?
Your answer should be very brief. 0.05. What is the ratio of the Amount (in current US$) in Malawi in 2000 to that in 2005?
Your response must be concise. 1.69. What is the ratio of the Amount (in current US$) in Mali in 2000 to that in 2005?
Make the answer very short. 0.22. What is the ratio of the Amount (in current US$) of Rwanda in 2000 to that in 2005?
Your answer should be compact. 0.37. What is the ratio of the Amount (in current US$) of Senegal in 2000 to that in 2005?
Your answer should be very brief. 0.04. What is the ratio of the Amount (in current US$) in Malawi in 2000 to that in 2006?
Keep it short and to the point. 1.38. What is the ratio of the Amount (in current US$) of Mali in 2000 to that in 2006?
Provide a succinct answer. 0.57. What is the ratio of the Amount (in current US$) of Rwanda in 2000 to that in 2006?
Keep it short and to the point. 0.57. What is the ratio of the Amount (in current US$) of Senegal in 2000 to that in 2006?
Make the answer very short. 0.07. What is the ratio of the Amount (in current US$) in Malawi in 2001 to that in 2002?
Offer a very short reply. 1.5. What is the ratio of the Amount (in current US$) in Mali in 2001 to that in 2002?
Your answer should be compact. 0.65. What is the ratio of the Amount (in current US$) of Rwanda in 2001 to that in 2002?
Your answer should be compact. 0.7. What is the ratio of the Amount (in current US$) of Senegal in 2001 to that in 2002?
Ensure brevity in your answer.  1.39. What is the ratio of the Amount (in current US$) of Malawi in 2001 to that in 2003?
Offer a terse response. 1.44. What is the ratio of the Amount (in current US$) of Mali in 2001 to that in 2003?
Your answer should be very brief. 0.42. What is the ratio of the Amount (in current US$) in Rwanda in 2001 to that in 2003?
Your answer should be compact. 2.75. What is the ratio of the Amount (in current US$) of Senegal in 2001 to that in 2003?
Your response must be concise. 1.58. What is the ratio of the Amount (in current US$) of Malawi in 2001 to that in 2004?
Ensure brevity in your answer.  1.53. What is the ratio of the Amount (in current US$) in Mali in 2001 to that in 2004?
Provide a succinct answer. 0.59. What is the ratio of the Amount (in current US$) of Rwanda in 2001 to that in 2004?
Give a very brief answer. 0.61. What is the ratio of the Amount (in current US$) of Senegal in 2001 to that in 2004?
Make the answer very short. 0.58. What is the ratio of the Amount (in current US$) in Malawi in 2001 to that in 2005?
Make the answer very short. 1.8. What is the ratio of the Amount (in current US$) in Mali in 2001 to that in 2005?
Give a very brief answer. 0.29. What is the ratio of the Amount (in current US$) of Rwanda in 2001 to that in 2005?
Your response must be concise. 0.74. What is the ratio of the Amount (in current US$) of Senegal in 2001 to that in 2005?
Offer a terse response. 0.46. What is the ratio of the Amount (in current US$) in Malawi in 2001 to that in 2006?
Your response must be concise. 1.47. What is the ratio of the Amount (in current US$) of Mali in 2001 to that in 2006?
Offer a terse response. 0.77. What is the ratio of the Amount (in current US$) of Rwanda in 2001 to that in 2006?
Your answer should be compact. 1.14. What is the ratio of the Amount (in current US$) in Senegal in 2001 to that in 2006?
Your answer should be very brief. 0.85. What is the ratio of the Amount (in current US$) in Malawi in 2002 to that in 2003?
Ensure brevity in your answer.  0.96. What is the ratio of the Amount (in current US$) in Mali in 2002 to that in 2003?
Offer a terse response. 0.65. What is the ratio of the Amount (in current US$) of Rwanda in 2002 to that in 2003?
Offer a very short reply. 3.91. What is the ratio of the Amount (in current US$) of Senegal in 2002 to that in 2003?
Offer a very short reply. 1.14. What is the ratio of the Amount (in current US$) in Malawi in 2002 to that in 2004?
Keep it short and to the point. 1.02. What is the ratio of the Amount (in current US$) of Mali in 2002 to that in 2004?
Your answer should be very brief. 0.92. What is the ratio of the Amount (in current US$) in Rwanda in 2002 to that in 2004?
Offer a terse response. 0.87. What is the ratio of the Amount (in current US$) in Senegal in 2002 to that in 2004?
Offer a very short reply. 0.41. What is the ratio of the Amount (in current US$) of Malawi in 2002 to that in 2005?
Your response must be concise. 1.2. What is the ratio of the Amount (in current US$) in Mali in 2002 to that in 2005?
Offer a terse response. 0.45. What is the ratio of the Amount (in current US$) in Rwanda in 2002 to that in 2005?
Your response must be concise. 1.06. What is the ratio of the Amount (in current US$) of Senegal in 2002 to that in 2005?
Your answer should be very brief. 0.33. What is the ratio of the Amount (in current US$) in Malawi in 2002 to that in 2006?
Make the answer very short. 0.98. What is the ratio of the Amount (in current US$) of Mali in 2002 to that in 2006?
Your answer should be very brief. 1.19. What is the ratio of the Amount (in current US$) in Rwanda in 2002 to that in 2006?
Ensure brevity in your answer.  1.62. What is the ratio of the Amount (in current US$) of Senegal in 2002 to that in 2006?
Offer a very short reply. 0.61. What is the ratio of the Amount (in current US$) of Malawi in 2003 to that in 2004?
Offer a very short reply. 1.06. What is the ratio of the Amount (in current US$) of Mali in 2003 to that in 2004?
Give a very brief answer. 1.41. What is the ratio of the Amount (in current US$) in Rwanda in 2003 to that in 2004?
Provide a succinct answer. 0.22. What is the ratio of the Amount (in current US$) of Senegal in 2003 to that in 2004?
Give a very brief answer. 0.36. What is the ratio of the Amount (in current US$) of Malawi in 2003 to that in 2005?
Offer a terse response. 1.25. What is the ratio of the Amount (in current US$) in Mali in 2003 to that in 2005?
Offer a terse response. 0.7. What is the ratio of the Amount (in current US$) of Rwanda in 2003 to that in 2005?
Keep it short and to the point. 0.27. What is the ratio of the Amount (in current US$) in Senegal in 2003 to that in 2005?
Offer a very short reply. 0.29. What is the ratio of the Amount (in current US$) of Malawi in 2003 to that in 2006?
Provide a short and direct response. 1.02. What is the ratio of the Amount (in current US$) in Mali in 2003 to that in 2006?
Provide a short and direct response. 1.83. What is the ratio of the Amount (in current US$) of Rwanda in 2003 to that in 2006?
Your answer should be very brief. 0.41. What is the ratio of the Amount (in current US$) of Senegal in 2003 to that in 2006?
Keep it short and to the point. 0.53. What is the ratio of the Amount (in current US$) of Malawi in 2004 to that in 2005?
Provide a succinct answer. 1.18. What is the ratio of the Amount (in current US$) of Mali in 2004 to that in 2005?
Your answer should be very brief. 0.49. What is the ratio of the Amount (in current US$) in Rwanda in 2004 to that in 2005?
Ensure brevity in your answer.  1.21. What is the ratio of the Amount (in current US$) of Senegal in 2004 to that in 2005?
Offer a terse response. 0.8. What is the ratio of the Amount (in current US$) of Malawi in 2004 to that in 2006?
Your response must be concise. 0.96. What is the ratio of the Amount (in current US$) in Mali in 2004 to that in 2006?
Provide a succinct answer. 1.29. What is the ratio of the Amount (in current US$) of Rwanda in 2004 to that in 2006?
Provide a succinct answer. 1.85. What is the ratio of the Amount (in current US$) of Senegal in 2004 to that in 2006?
Offer a very short reply. 1.47. What is the ratio of the Amount (in current US$) of Malawi in 2005 to that in 2006?
Give a very brief answer. 0.81. What is the ratio of the Amount (in current US$) of Mali in 2005 to that in 2006?
Offer a terse response. 2.62. What is the ratio of the Amount (in current US$) in Rwanda in 2005 to that in 2006?
Your answer should be very brief. 1.53. What is the ratio of the Amount (in current US$) in Senegal in 2005 to that in 2006?
Make the answer very short. 1.83. What is the difference between the highest and the second highest Amount (in current US$) in Malawi?
Provide a succinct answer. 5.60e+06. What is the difference between the highest and the second highest Amount (in current US$) in Mali?
Provide a short and direct response. 6.89e+07. What is the difference between the highest and the second highest Amount (in current US$) of Rwanda?
Your answer should be very brief. 1.11e+07. What is the difference between the highest and the second highest Amount (in current US$) of Senegal?
Ensure brevity in your answer.  5.37e+07. What is the difference between the highest and the lowest Amount (in current US$) of Malawi?
Your response must be concise. 4.06e+07. What is the difference between the highest and the lowest Amount (in current US$) of Mali?
Provide a short and direct response. 1.79e+08. What is the difference between the highest and the lowest Amount (in current US$) of Rwanda?
Provide a succinct answer. 6.73e+07. What is the difference between the highest and the lowest Amount (in current US$) of Senegal?
Offer a terse response. 2.60e+08. 